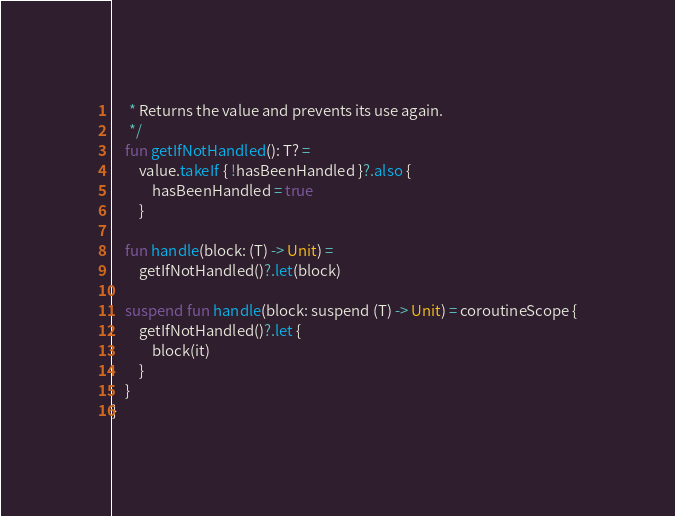Convert code to text. <code><loc_0><loc_0><loc_500><loc_500><_Kotlin_>     * Returns the value and prevents its use again.
     */
    fun getIfNotHandled(): T? =
        value.takeIf { !hasBeenHandled }?.also {
            hasBeenHandled = true
        }

    fun handle(block: (T) -> Unit) =
        getIfNotHandled()?.let(block)

    suspend fun handle(block: suspend (T) -> Unit) = coroutineScope {
        getIfNotHandled()?.let {
            block(it)
        }
    }
}
</code> 